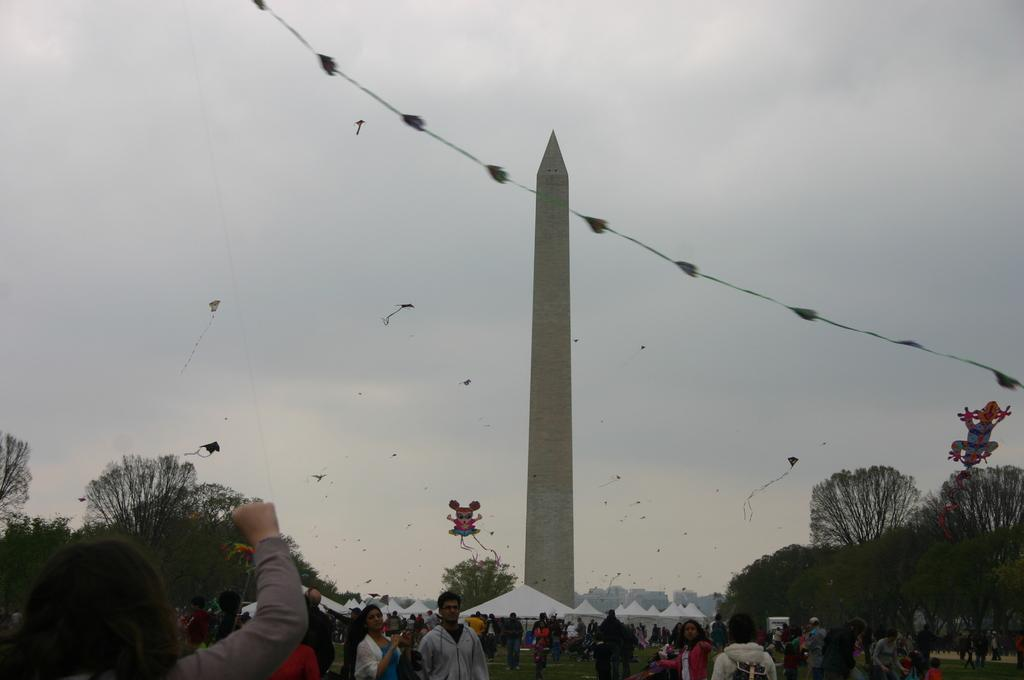What is one of the main structures in the image? There is a pillar in the image. What type of temporary shelters can be seen in the image? There are tents in the image. How many people are present in the image? There are many people in the image. What type of vegetation is visible in the image? There are trees in the image. What is visible in the background of the image? The sky is visible in the background of the image. What is happening in the sky? There are kites flying in the sky. What type of power source is visible in the image? There is no power source visible in the image. What type of flag is being flown by the people in the image? There is no flag visible in the image. 